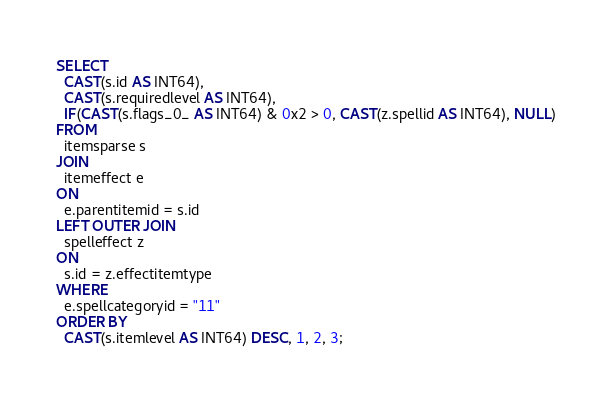Convert code to text. <code><loc_0><loc_0><loc_500><loc_500><_SQL_>SELECT
  CAST(s.id AS INT64),
  CAST(s.requiredlevel AS INT64),
  IF(CAST(s.flags_0_ AS INT64) & 0x2 > 0, CAST(z.spellid AS INT64), NULL)
FROM
  itemsparse s
JOIN
  itemeffect e
ON
  e.parentitemid = s.id
LEFT OUTER JOIN
  spelleffect z
ON
  s.id = z.effectitemtype
WHERE
  e.spellcategoryid = "11"
ORDER BY
  CAST(s.itemlevel AS INT64) DESC, 1, 2, 3;
</code> 